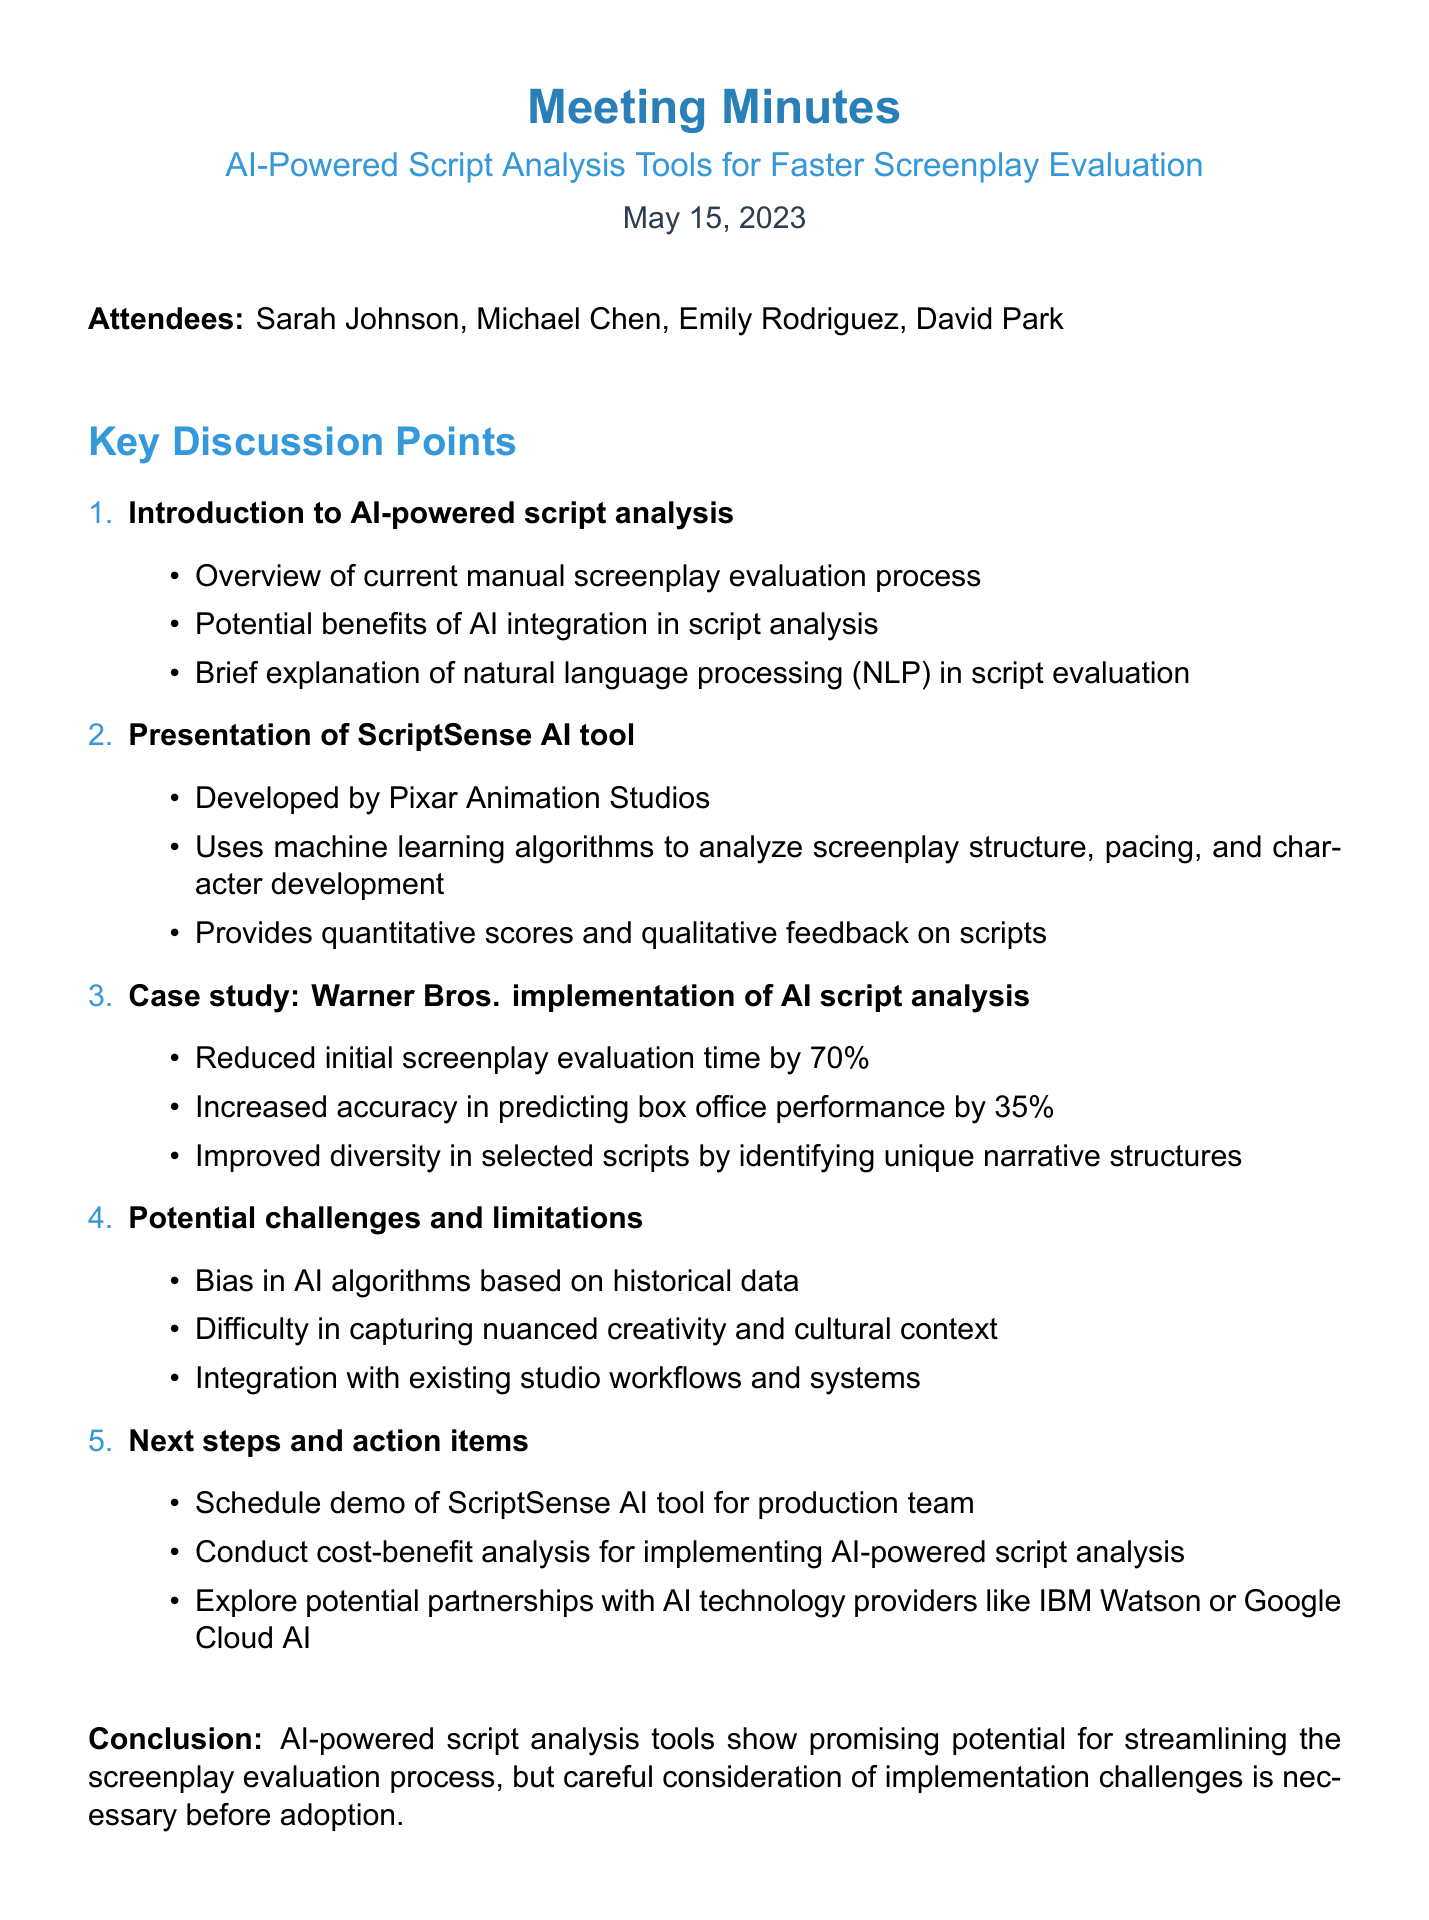What is the date of the meeting? The date of the meeting is explicitly stated in the document as May 15, 2023.
Answer: May 15, 2023 Who developed the ScriptSense AI tool? The document mentions that the ScriptSense AI tool was developed by Pixar Animation Studios.
Answer: Pixar Animation Studios What percentage did Warner Bros. reduce screenplay evaluation time by? The document provides the figure of 70% as the reduction in evaluation time by Warner Bros.
Answer: 70% What is one potential challenge mentioned regarding AI integration? The document lists bias in AI algorithms based on historical data as one of the challenges.
Answer: Bias in AI algorithms What is one of the next steps mentioned in the action items? The document states that one of the next steps is to schedule a demo of the ScriptSense AI tool for the production team.
Answer: Schedule demo of ScriptSense AI tool 